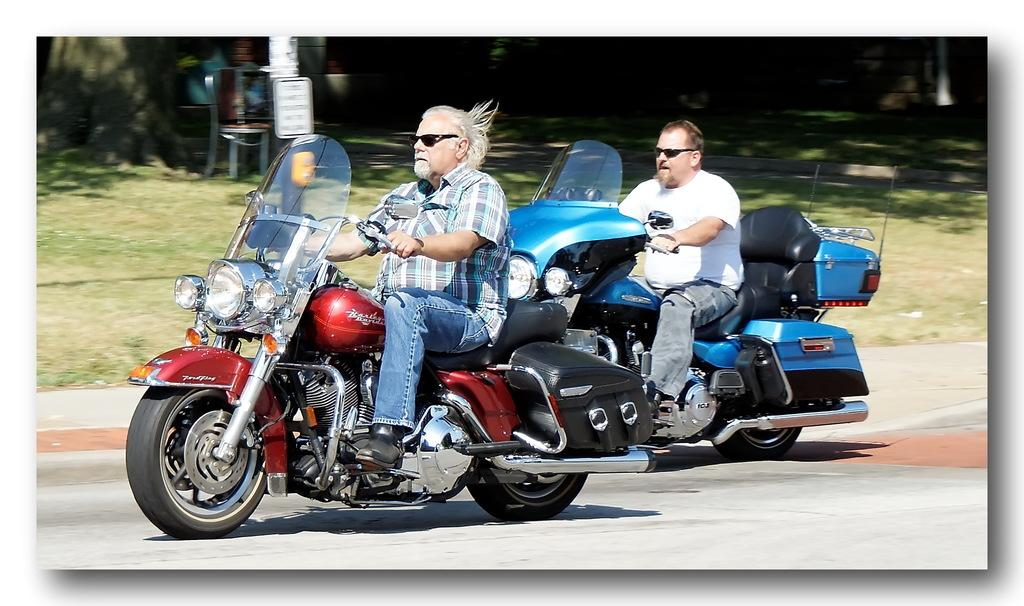How many people are riding the motorbike in the image? There are two persons riding the motorbike in the image. Where is the motorbike located? The motorbike is in the street. What can be seen in the background of the image? In the background of the image, there are plants, trees, a pole, a name board, chairs, and grass. Can you describe the pattern on the giraffe's fur in the image? There is no giraffe present in the image, so we cannot describe its fur pattern. 